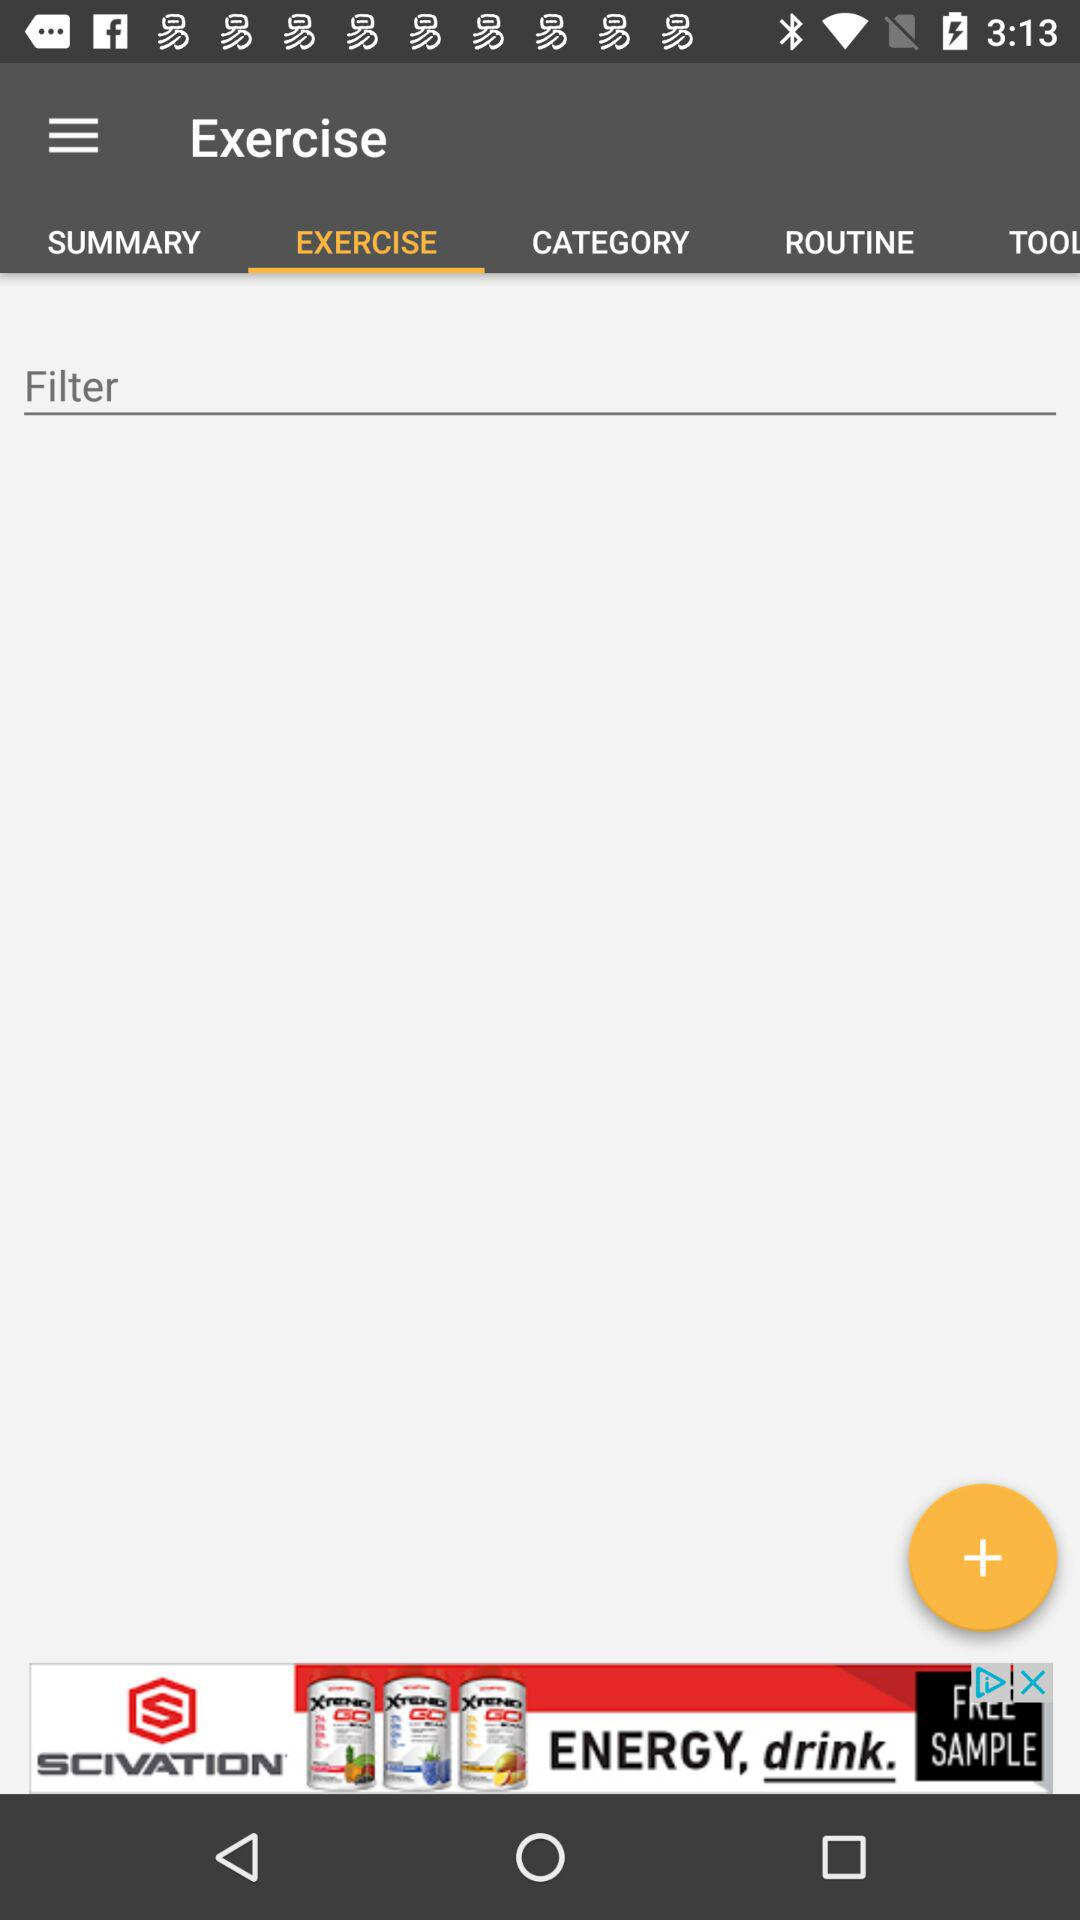Which tab has been selected? The tab that has been selected is "EXERCISE". 